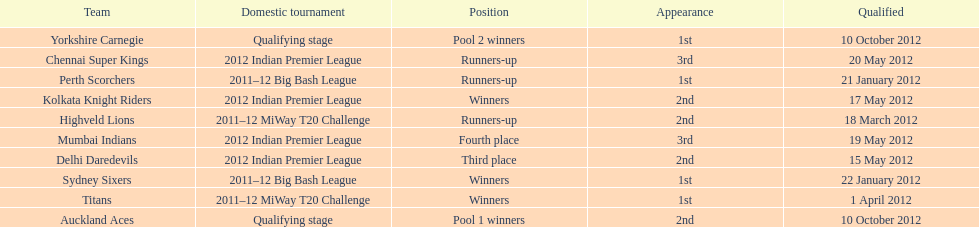What is the total number of teams? 10. 